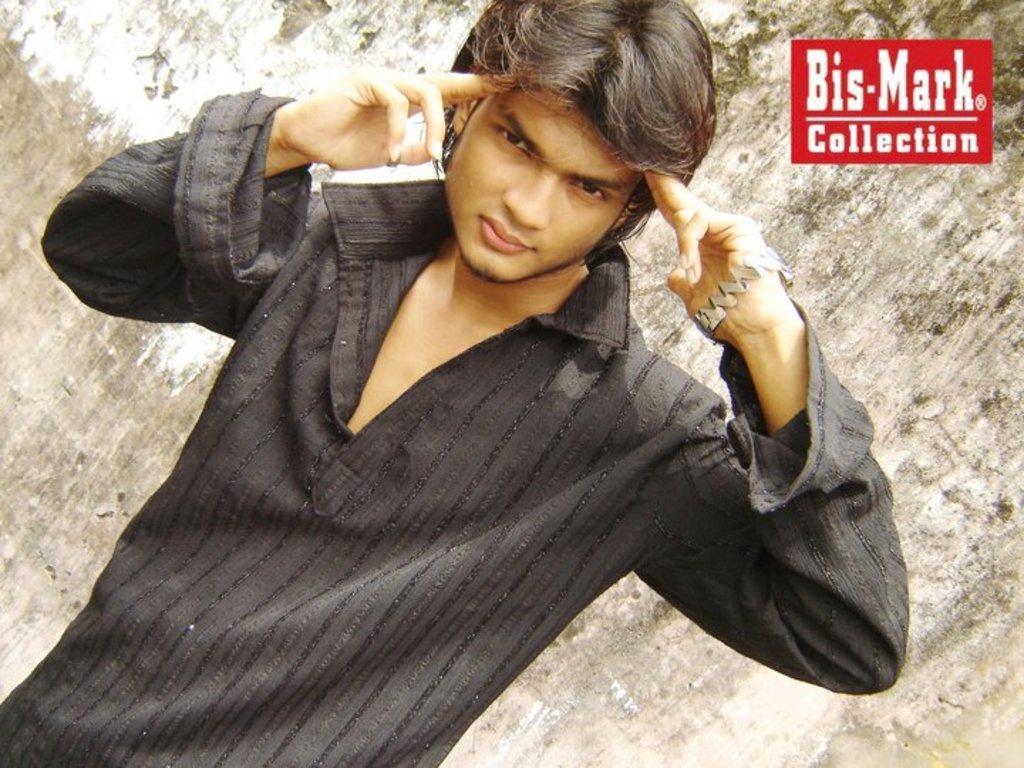Can you describe this image briefly? There is a man wearing a black dress. In the back there is a wall. In the right top corner there is a watermark. 